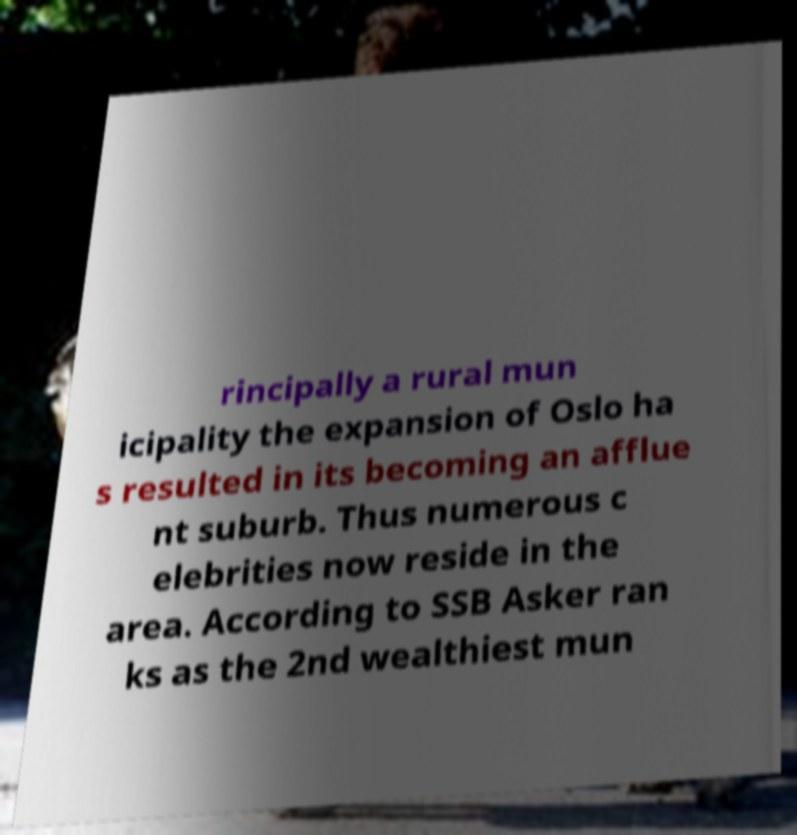There's text embedded in this image that I need extracted. Can you transcribe it verbatim? rincipally a rural mun icipality the expansion of Oslo ha s resulted in its becoming an afflue nt suburb. Thus numerous c elebrities now reside in the area. According to SSB Asker ran ks as the 2nd wealthiest mun 